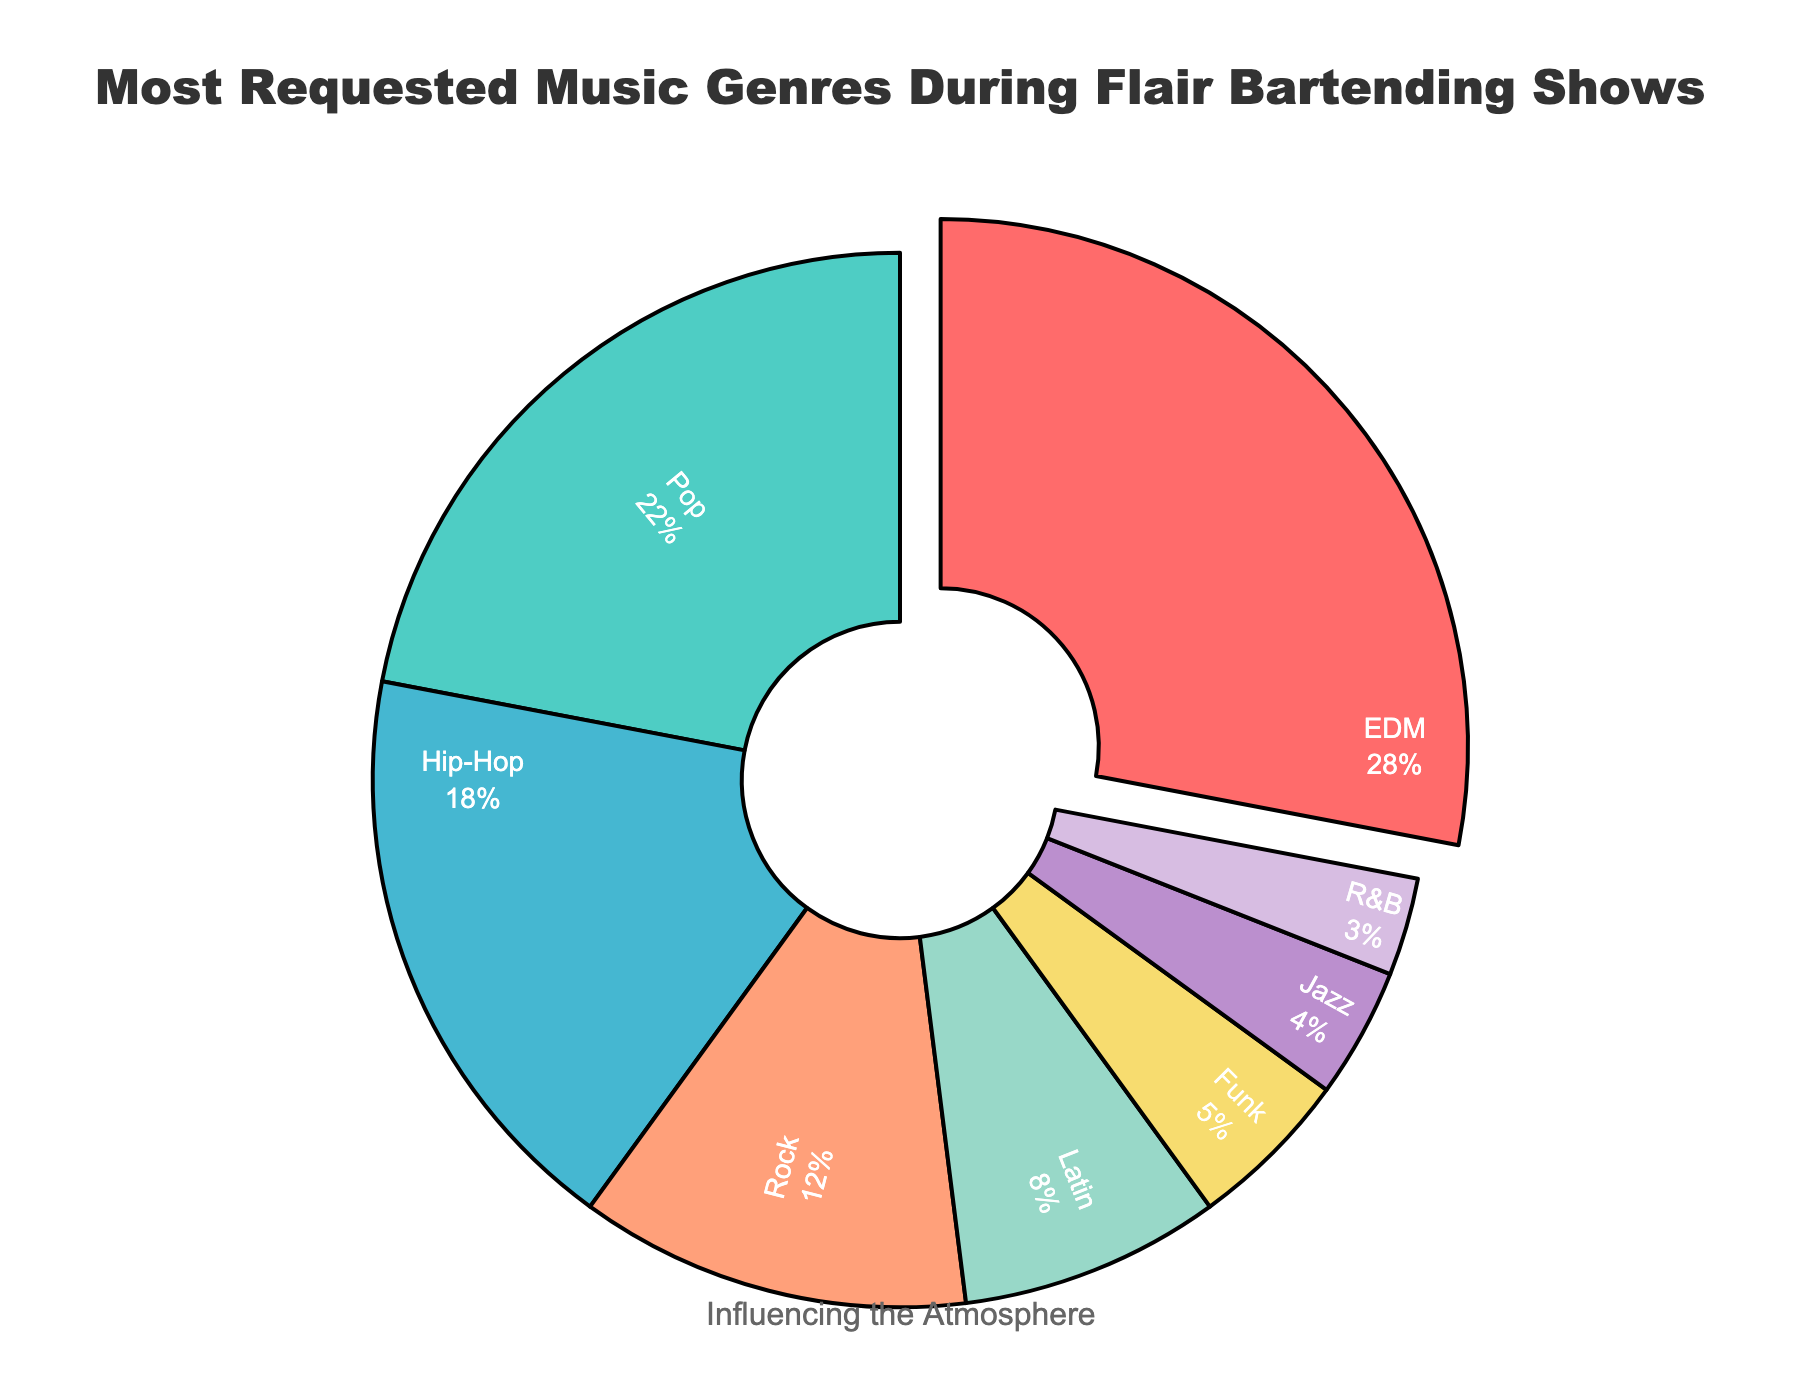What's the most requested music genre during flair bartending shows? The pie chart prominently highlights the genre with the highest percentage by slightly pulling it out from the rest. This genre is also labeled with the largest percentage.
Answer: EDM Which music genre has the least request during flair bartending shows? Looking at the pie chart, identify the slice with the smallest percentage value. This slice is labeled with its genre.
Answer: R&B How much more popular is EDM compared to Hip-Hop? First, find the percentages for EDM and Hip-Hop from the figure. EDM is 28%, and Hip-Hop is 18%. Subtract the percentage of Hip-Hop from EDM (28% - 18%).
Answer: 10% What is the combined percentage of Pop and Rock genres? Locate the slices for Pop and Rock. Pop has a percentage of 22% and Rock has 12%. Add these two percentages together (22% + 12%).
Answer: 34% Between Latin and Jazz genres, which one is requested more and by how much? Check the percentages for Latin and Jazz on the pie chart. Latin is 8% and Jazz is 4%. Subtract the Jazz percentage from the Latin percentage (8% - 4%).
Answer: Latin, by 4% What percentage of the total requests do Funk and R&B together account for? Identify the slices corresponding to Funk (5%) and R&B (3%). Add their percentages together (5% + 3%).
Answer: 8% Is Rock more popular than Hip-Hop? Find the percentages for Rock (12%) and Hip-Hop (18%) on the chart. Compare the two values. Rock's percentage is less than Hip-Hop's.
Answer: No What is the second most requested music genre during flair bartending shows? After identifying the most requested genre (EDM), find the genre with the next highest percentage. This is Pop with 22%.
Answer: Pop What is the difference in popularity between the most requested genre and the least requested genre? Subtract the percentage of the least requested genre (R&B, 3%) from the most requested genre (EDM, 28%) to find the difference (28% - 3%).
Answer: 25% How much more do EDM and Pop together contribute compared to all other genres combined? Add the percentages for EDM (28%) and Pop (22%) to get their combined total (50%). Subtract this from 100% to get the combined percentage of the other genres (100% - 50% = 50%). The difference between the combined percentages of EDM and Pop and all other genres is zero.
Answer: 0% 